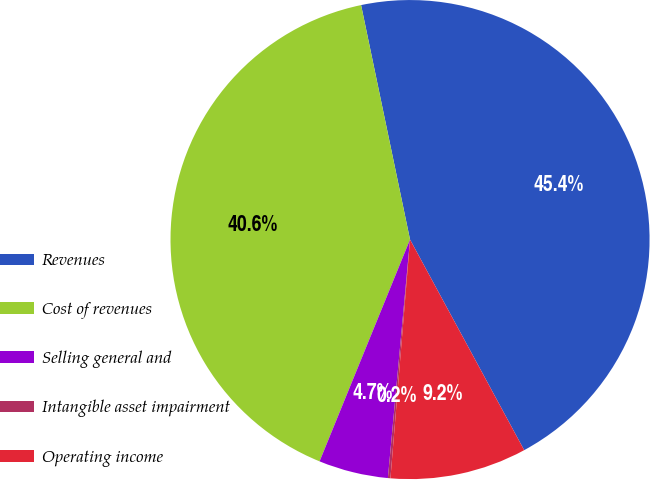Convert chart. <chart><loc_0><loc_0><loc_500><loc_500><pie_chart><fcel>Revenues<fcel>Cost of revenues<fcel>Selling general and<fcel>Intangible asset impairment<fcel>Operating income<nl><fcel>45.37%<fcel>40.56%<fcel>4.69%<fcel>0.17%<fcel>9.21%<nl></chart> 